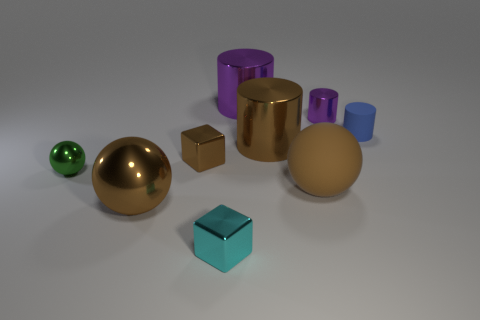Subtract all blue spheres. How many purple cylinders are left? 2 Subtract all brown matte balls. How many balls are left? 2 Subtract all brown cylinders. How many cylinders are left? 3 Subtract 1 cylinders. How many cylinders are left? 3 Subtract all spheres. How many objects are left? 6 Subtract all red balls. Subtract all yellow cylinders. How many balls are left? 3 Subtract 1 blue cylinders. How many objects are left? 8 Subtract all red metallic cylinders. Subtract all small green spheres. How many objects are left? 8 Add 7 cyan shiny objects. How many cyan shiny objects are left? 8 Add 1 big purple rubber spheres. How many big purple rubber spheres exist? 1 